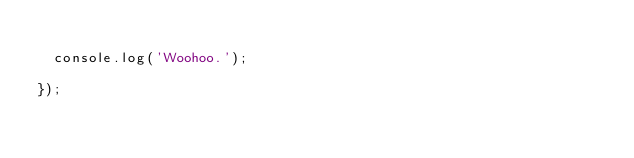<code> <loc_0><loc_0><loc_500><loc_500><_JavaScript_>
  console.log('Woohoo.');

});
</code> 